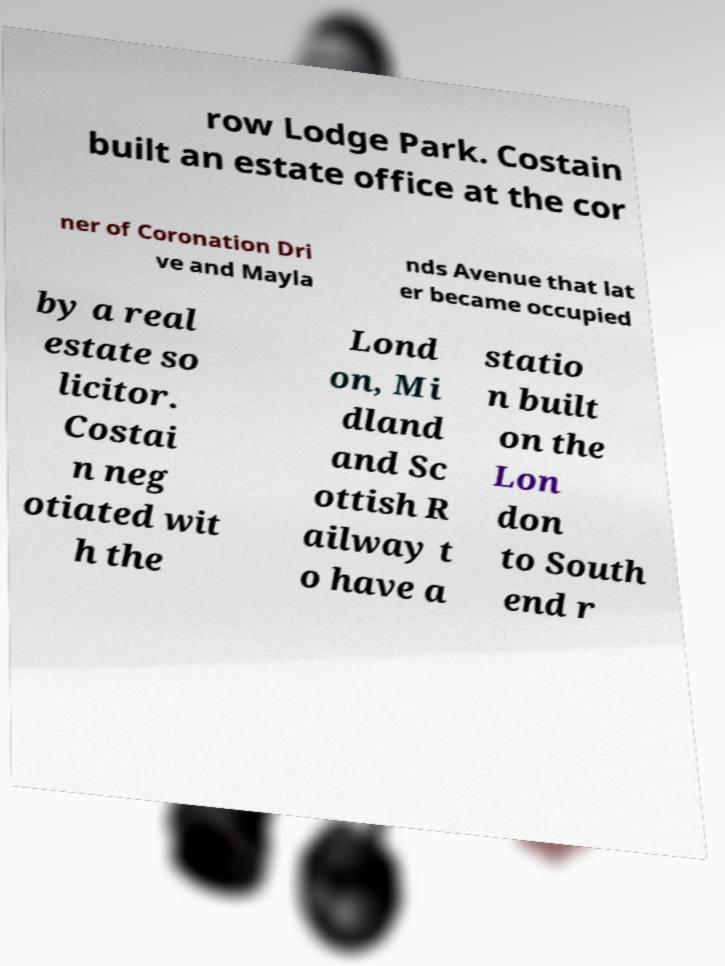Can you read and provide the text displayed in the image?This photo seems to have some interesting text. Can you extract and type it out for me? row Lodge Park. Costain built an estate office at the cor ner of Coronation Dri ve and Mayla nds Avenue that lat er became occupied by a real estate so licitor. Costai n neg otiated wit h the Lond on, Mi dland and Sc ottish R ailway t o have a statio n built on the Lon don to South end r 